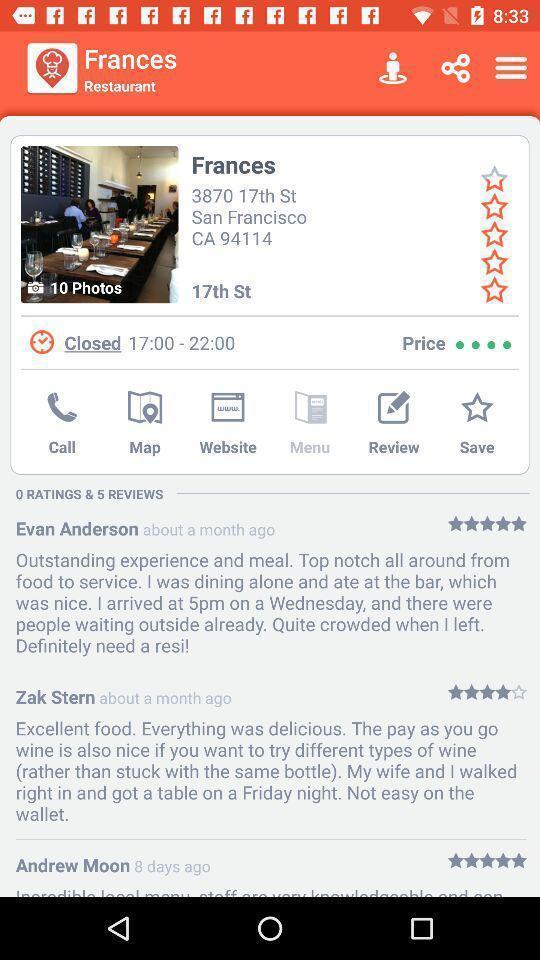What is the overall content of this screenshot? Screen displaying multiple users reviews information. 